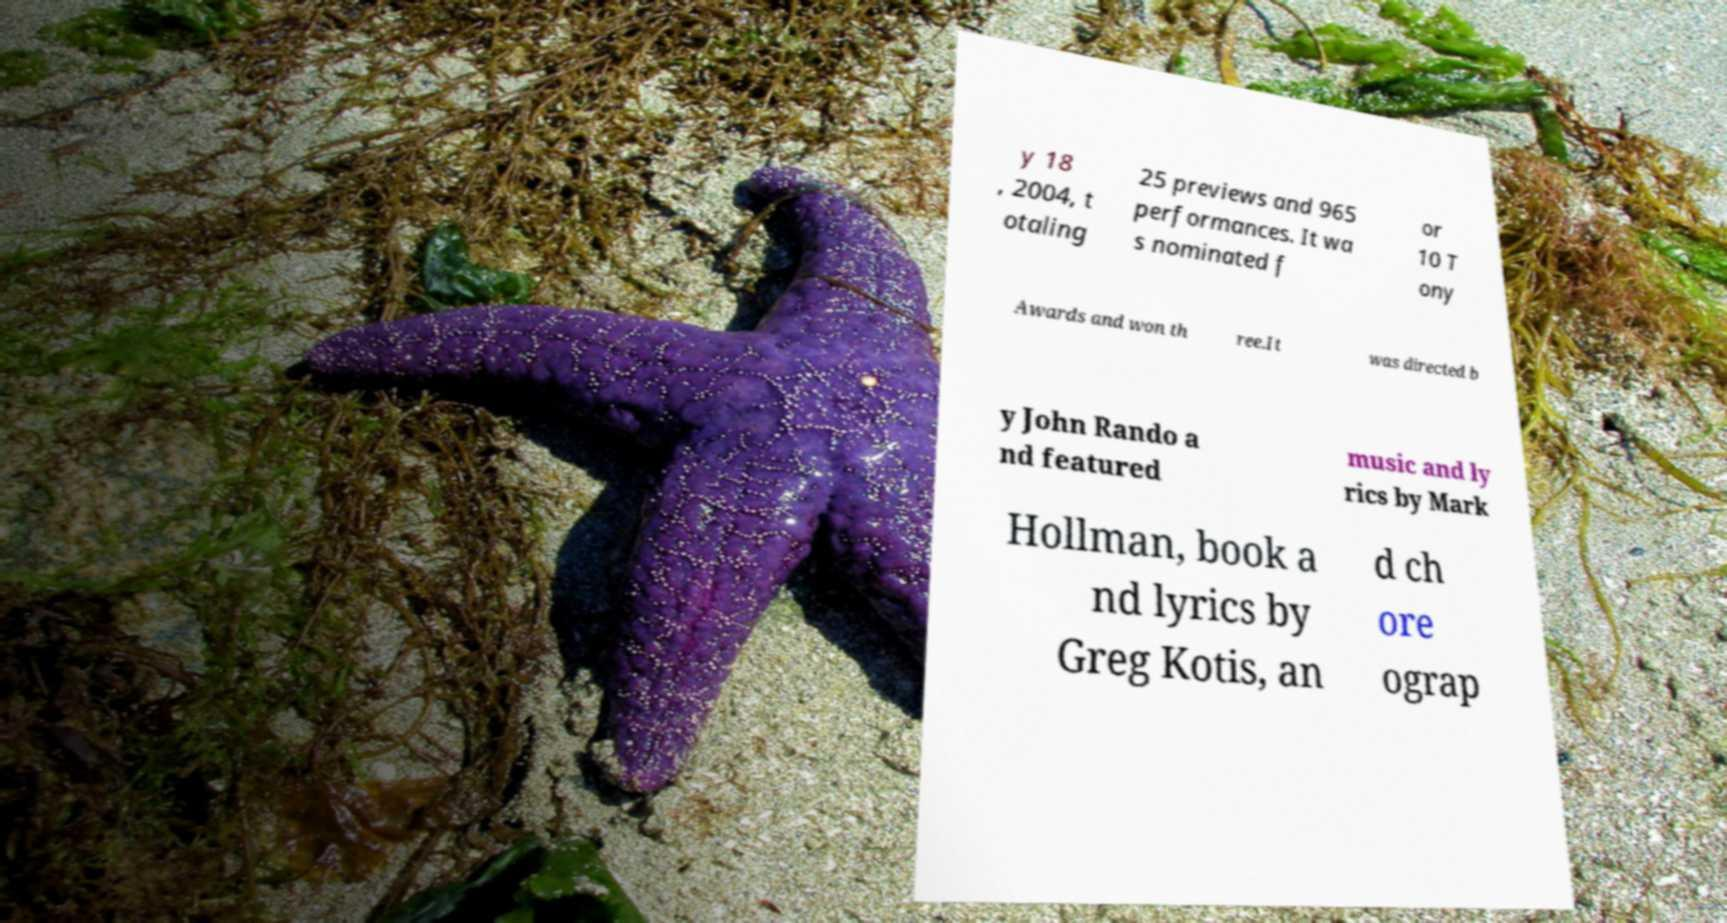There's text embedded in this image that I need extracted. Can you transcribe it verbatim? y 18 , 2004, t otaling 25 previews and 965 performances. It wa s nominated f or 10 T ony Awards and won th ree.It was directed b y John Rando a nd featured music and ly rics by Mark Hollman, book a nd lyrics by Greg Kotis, an d ch ore ograp 